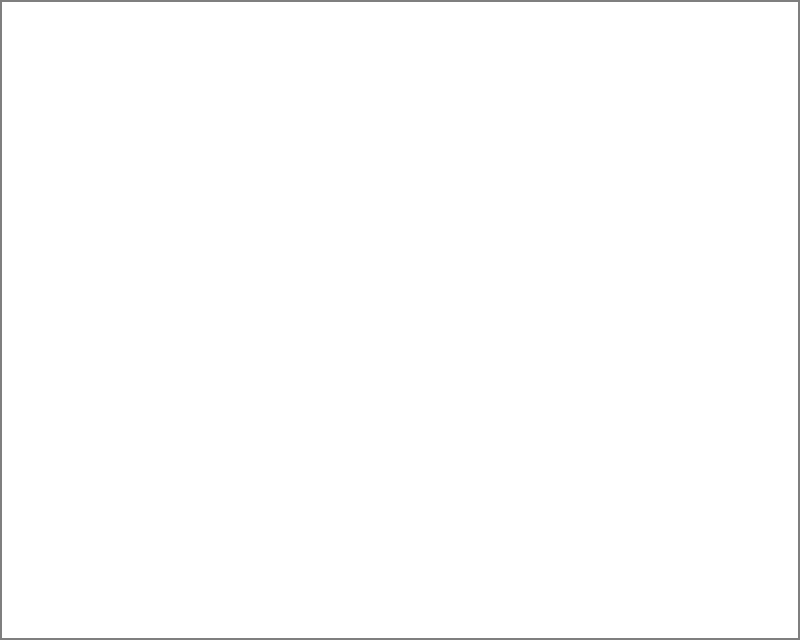In the school layout shown, three emergency alarms (A, B, and C) are represented by vectors from the origin to their respective positions. The coverage area of each alarm is shown by a circle with a radius of 3 units. What is the total area of the school that is covered by at least two alarm systems, expressed in square units? To solve this problem, we need to follow these steps:

1. Identify the areas covered by at least two alarms:
   - The overlap between alarms A and B
   - The overlap between alarms B and C
   - The overlap between alarms A and C

2. Calculate the area of each overlap using the formula for the area of intersection of two circles:
   $A = 2r^2 \arccos(\frac{d}{2r}) - d\sqrt{r^2 - \frac{d^2}{4}}$
   Where $r$ is the radius (3 units) and $d$ is the distance between circle centers.

3. Calculate the distances between alarm centers:
   - $d_{AB} = \sqrt{(8-2)^2 + (2-2)^2} = 6$ units
   - $d_{BC} = \sqrt{(8-5)^2 + (2-6)^2} = 5$ units
   - $d_{AC} = \sqrt{(5-2)^2 + (6-2)^2} = 5$ units

4. Calculate the areas of overlap:
   - $A_{AB} = 2(3^2)\arccos(\frac{6}{2(3)}) - 6\sqrt{3^2 - \frac{6^2}{4}} \approx 2.29$ sq units
   - $A_{BC} = 2(3^2)\arccos(\frac{5}{2(3)}) - 5\sqrt{3^2 - \frac{5^2}{4}} \approx 5.39$ sq units
   - $A_{AC} = 2(3^2)\arccos(\frac{5}{2(3)}) - 5\sqrt{3^2 - \frac{5^2}{4}} \approx 5.39$ sq units

5. Sum up the areas of overlap:
   Total area covered by at least two alarms = $A_{AB} + A_{BC} + A_{AC} \approx 2.29 + 5.39 + 5.39 = 13.07$ sq units
Answer: 13.07 square units 